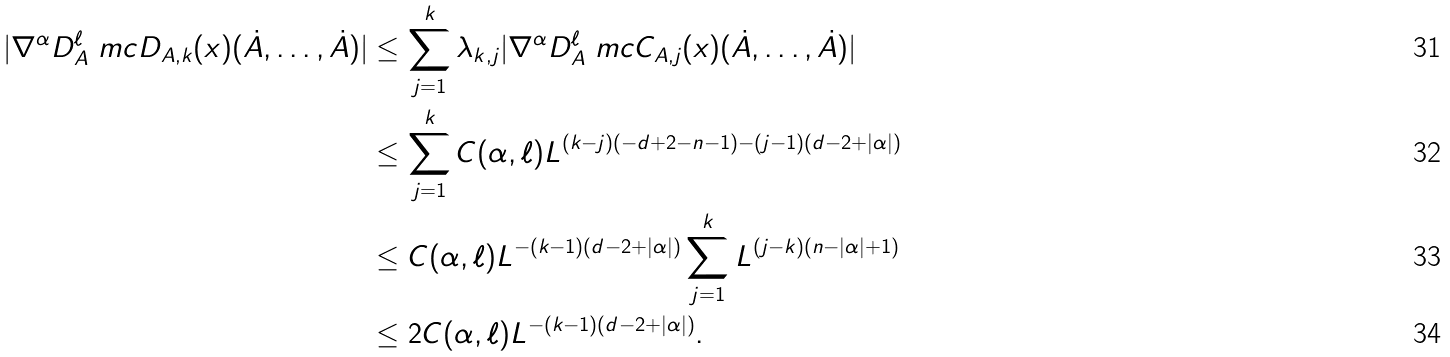Convert formula to latex. <formula><loc_0><loc_0><loc_500><loc_500>| \nabla ^ { \alpha } D _ { A } ^ { \ell } \ m c { D } _ { A , k } ( x ) ( \dot { A } , \dots , \dot { A } ) | & \leq \sum _ { j = 1 } ^ { k } \lambda _ { k , j } | \nabla ^ { \alpha } D _ { A } ^ { \ell } \ m c { C } _ { A , j } ( x ) ( \dot { A } , \dots , \dot { A } ) | \\ & \leq \sum _ { j = 1 } ^ { k } C ( \alpha , \ell ) L ^ { ( k - j ) ( - d + 2 - n - 1 ) - ( j - 1 ) ( d - 2 + | \alpha | ) } \\ & \leq C ( \alpha , \ell ) L ^ { - ( k - 1 ) ( d - 2 + | \alpha | ) } \sum _ { j = 1 } ^ { k } L ^ { ( j - k ) ( n - | \alpha | + 1 ) } \\ & \leq 2 C ( \alpha , \ell ) L ^ { - ( k - 1 ) ( d - 2 + | \alpha | ) } .</formula> 